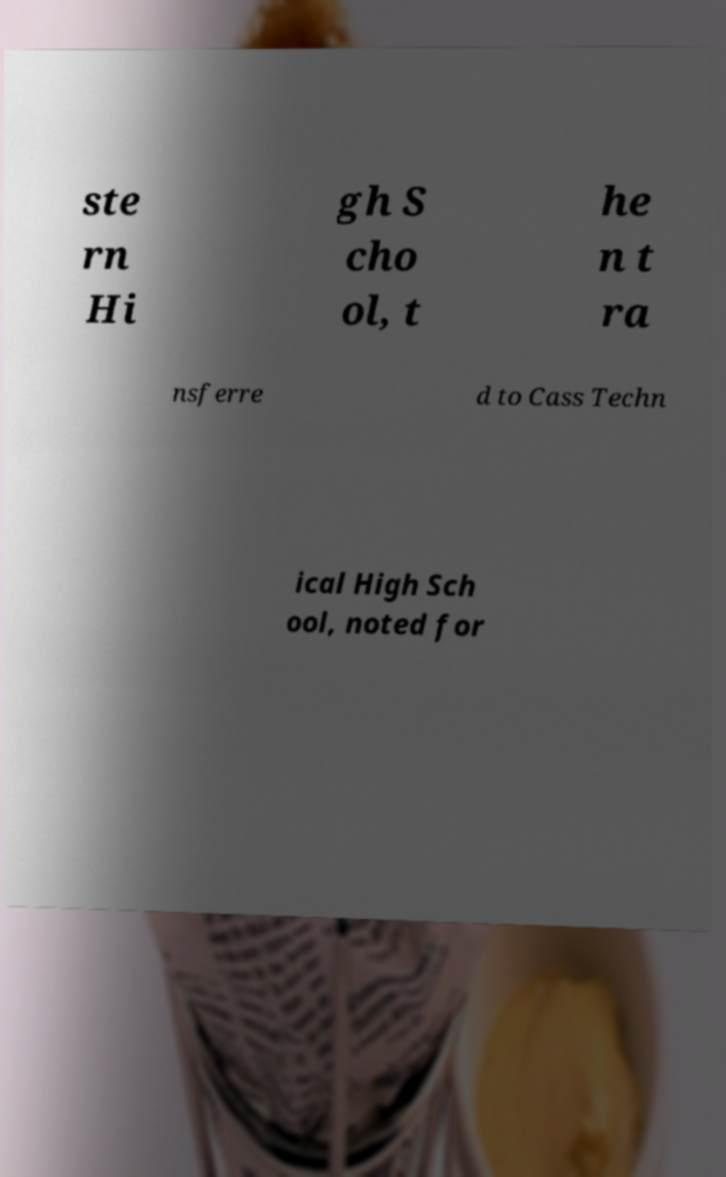Can you accurately transcribe the text from the provided image for me? ste rn Hi gh S cho ol, t he n t ra nsferre d to Cass Techn ical High Sch ool, noted for 